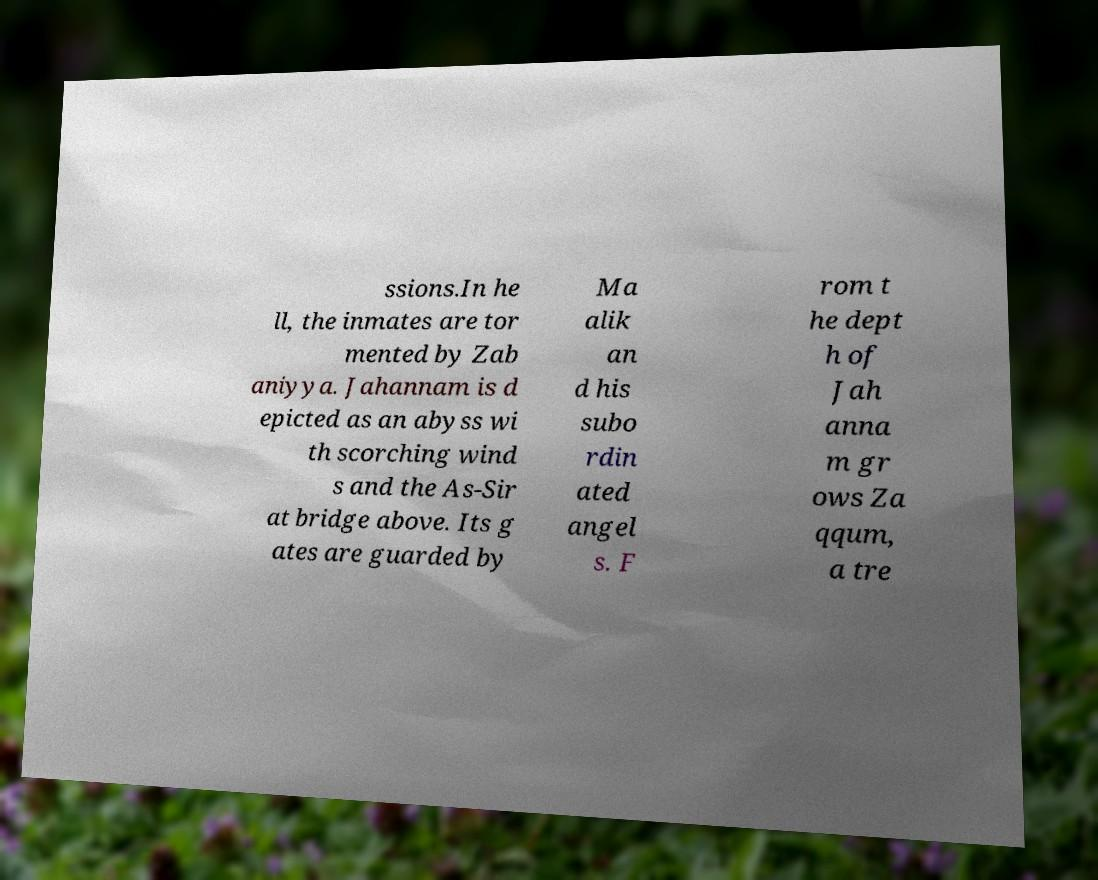Please read and relay the text visible in this image. What does it say? ssions.In he ll, the inmates are tor mented by Zab aniyya. Jahannam is d epicted as an abyss wi th scorching wind s and the As-Sir at bridge above. Its g ates are guarded by Ma alik an d his subo rdin ated angel s. F rom t he dept h of Jah anna m gr ows Za qqum, a tre 